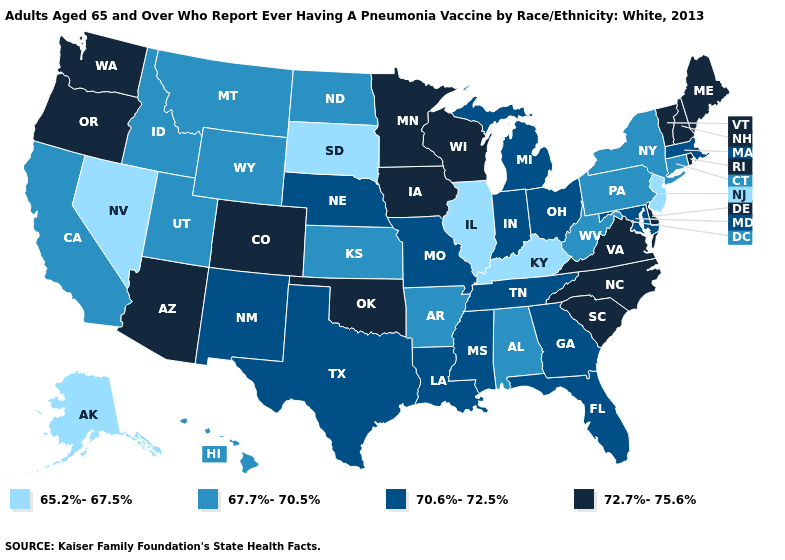Which states have the lowest value in the South?
Answer briefly. Kentucky. What is the value of Iowa?
Short answer required. 72.7%-75.6%. What is the value of Iowa?
Short answer required. 72.7%-75.6%. Which states have the lowest value in the USA?
Quick response, please. Alaska, Illinois, Kentucky, Nevada, New Jersey, South Dakota. What is the highest value in the USA?
Be succinct. 72.7%-75.6%. What is the value of Maryland?
Concise answer only. 70.6%-72.5%. Among the states that border New Hampshire , which have the highest value?
Short answer required. Maine, Vermont. Does California have the highest value in the West?
Short answer required. No. Among the states that border Idaho , does Nevada have the lowest value?
Write a very short answer. Yes. Does New York have the highest value in the Northeast?
Concise answer only. No. Among the states that border Arizona , which have the highest value?
Answer briefly. Colorado. Name the states that have a value in the range 65.2%-67.5%?
Give a very brief answer. Alaska, Illinois, Kentucky, Nevada, New Jersey, South Dakota. Does the first symbol in the legend represent the smallest category?
Quick response, please. Yes. Does Delaware have a higher value than Florida?
Concise answer only. Yes. Among the states that border Missouri , which have the highest value?
Be succinct. Iowa, Oklahoma. 